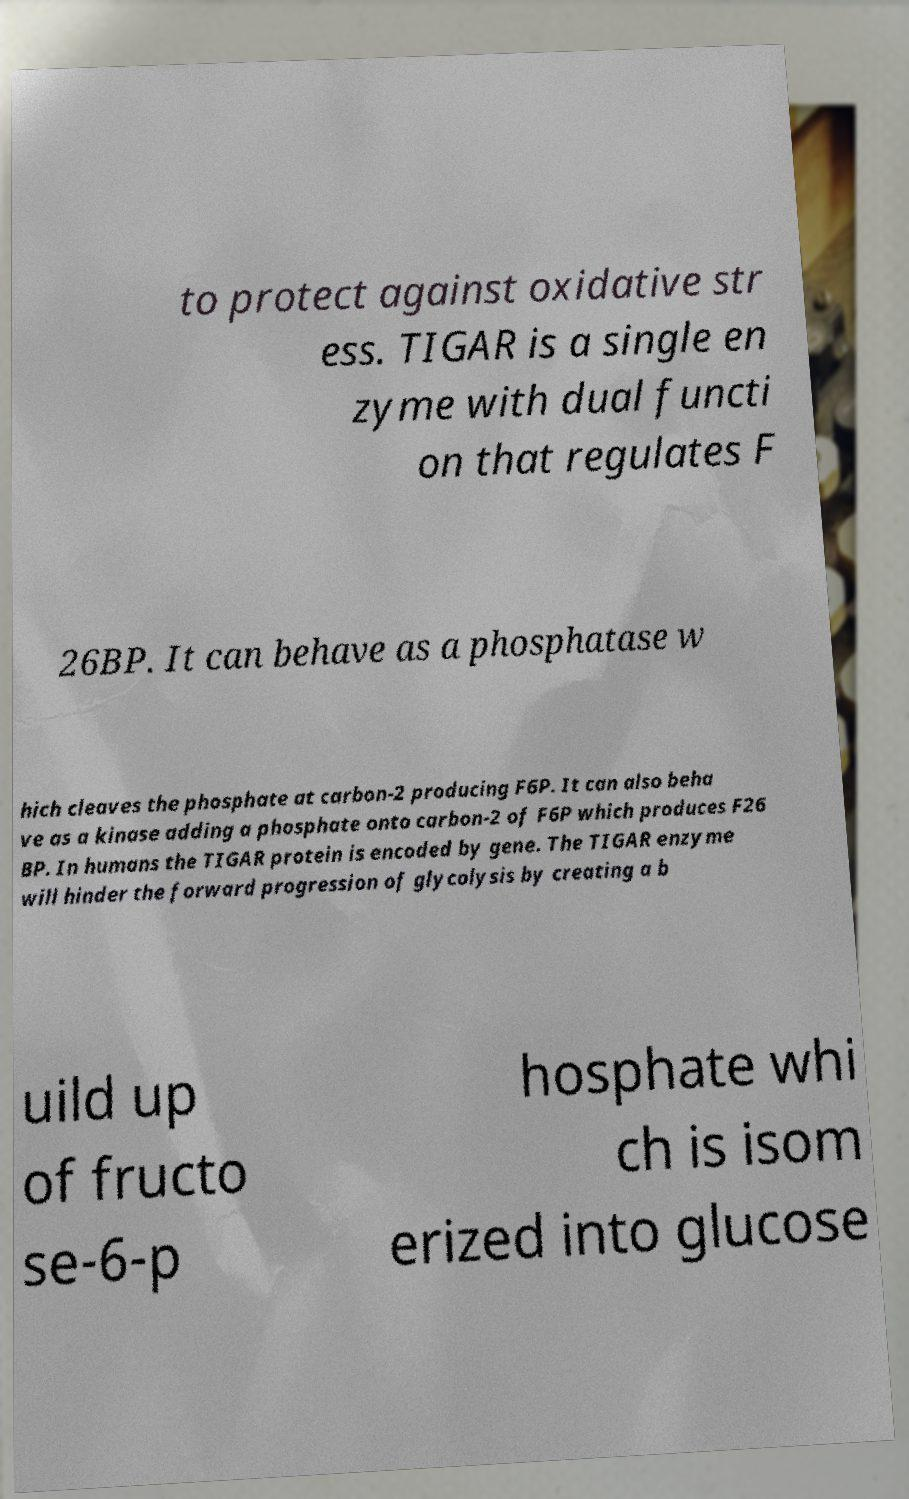Please identify and transcribe the text found in this image. to protect against oxidative str ess. TIGAR is a single en zyme with dual functi on that regulates F 26BP. It can behave as a phosphatase w hich cleaves the phosphate at carbon-2 producing F6P. It can also beha ve as a kinase adding a phosphate onto carbon-2 of F6P which produces F26 BP. In humans the TIGAR protein is encoded by gene. The TIGAR enzyme will hinder the forward progression of glycolysis by creating a b uild up of fructo se-6-p hosphate whi ch is isom erized into glucose 